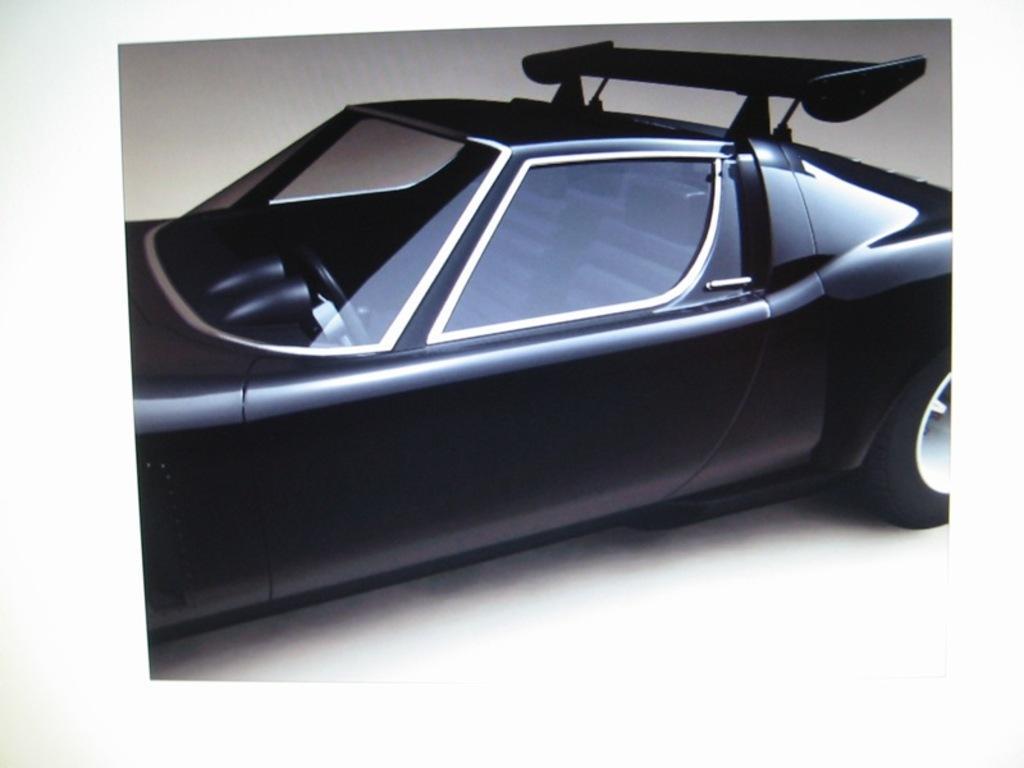Please provide a concise description of this image. In this picture I can see the vehicle. 